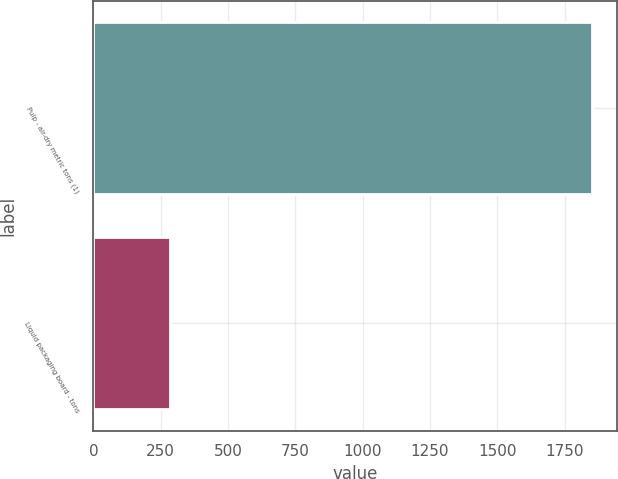Convert chart. <chart><loc_0><loc_0><loc_500><loc_500><bar_chart><fcel>Pulp - air-dry metric tons (1)<fcel>Liquid packaging board - tons<nl><fcel>1851<fcel>283<nl></chart> 